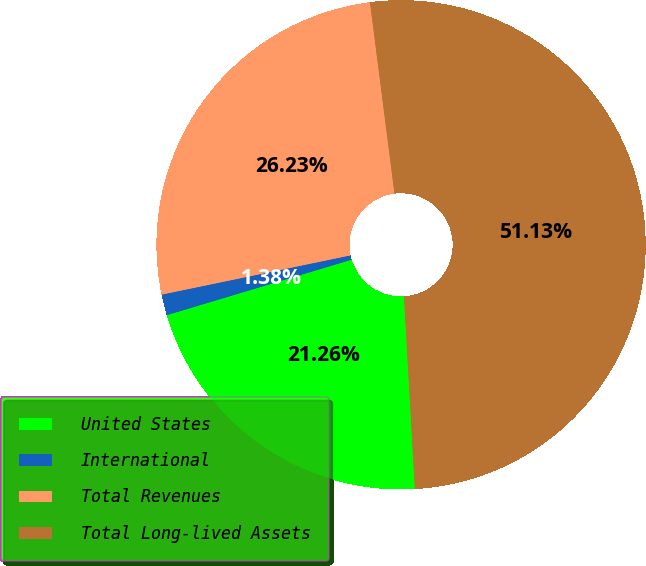Convert chart to OTSL. <chart><loc_0><loc_0><loc_500><loc_500><pie_chart><fcel>United States<fcel>International<fcel>Total Revenues<fcel>Total Long-lived Assets<nl><fcel>21.26%<fcel>1.38%<fcel>26.23%<fcel>51.13%<nl></chart> 